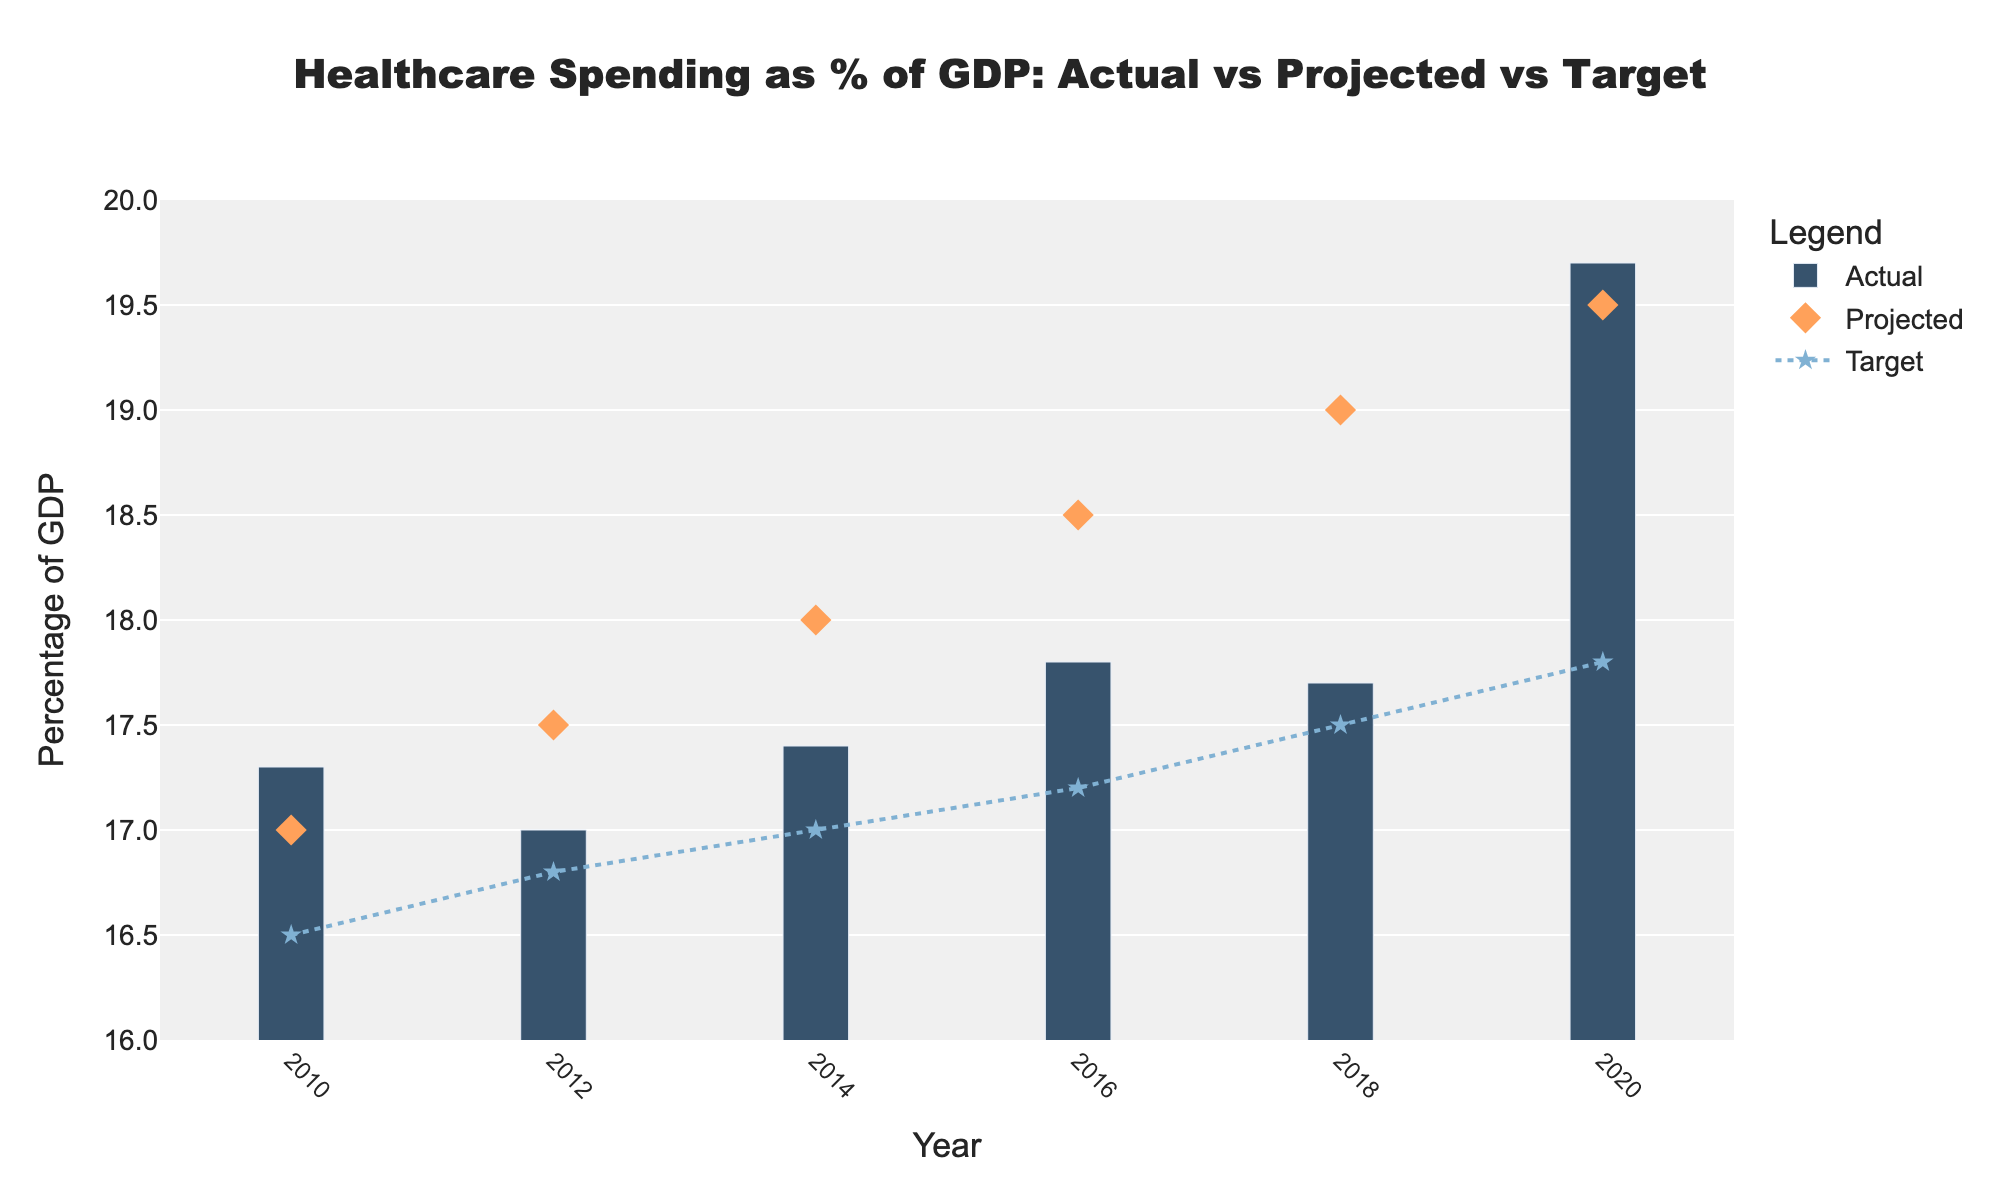what is the title of the plot? The title of the plot is usually placed at the top center and clearly labeled in a larger font compared to other text. In this figure, it states the main focus of the chart.
Answer: Healthcare Spending as % of GDP: Actual vs Projected vs Target How many years are represented in the plot? The x-axis in the plot represents the years. Counting the tick marks or the unique values along the x-axis gives us the number of years represented.
Answer: 6 In which year was the actual healthcare spending highest? Look at the bars labeled 'Actual' and identify the year where the bar is tallest.
Answer: 2020 How much higher was the actual spending in 2020 compared to the target? Identify the actual value and the target value for 2020 from the plot. Subtract the target value from the actual value to find the difference.
Answer: 1.9 (19.7 - 17.8) What was the projected value in 2016? Identify the marker displayed for 'Projected' in the year 2016. The value at this point is the projected healthcare spending for that year.
Answer: 18.5 Compare the actual spending and target in 2014. Was the actual spending higher or lower than the target? Look at the bar for actual spending and the line/marker for the target in 2014. Determine whether the bar is above or below the target line.
Answer: Higher Was the actual spending trend increasing, decreasing, or fluctuating from 2010 to 2020? Observe the height of the bars over the years 2010 to 2020 in sequence. Check whether the heights are generally rising, falling, or changing in a non-consistent manner.
Answer: Increasing In which year did the projected spending exceed the actual spending? Identify the points where the markers for 'Projected' are higher than the bars for 'Actual' in the same year.
Answer: 2018 Looking at the target values, was there a general trend of increasing or decreasing targets from 2010 to 2020? Observe the positions of the markers/line for the 'Target' values from 2010 to 2020 and see whether the values are generally rising or falling over time.
Answer: Increasing How does the actual spending in 2018 compare to the target? Compare the height of the bar for 'Actual' in 2018 with the position of the target line/marker. Determine whether the actual spending is higher or lower than the target.
Answer: Higher 